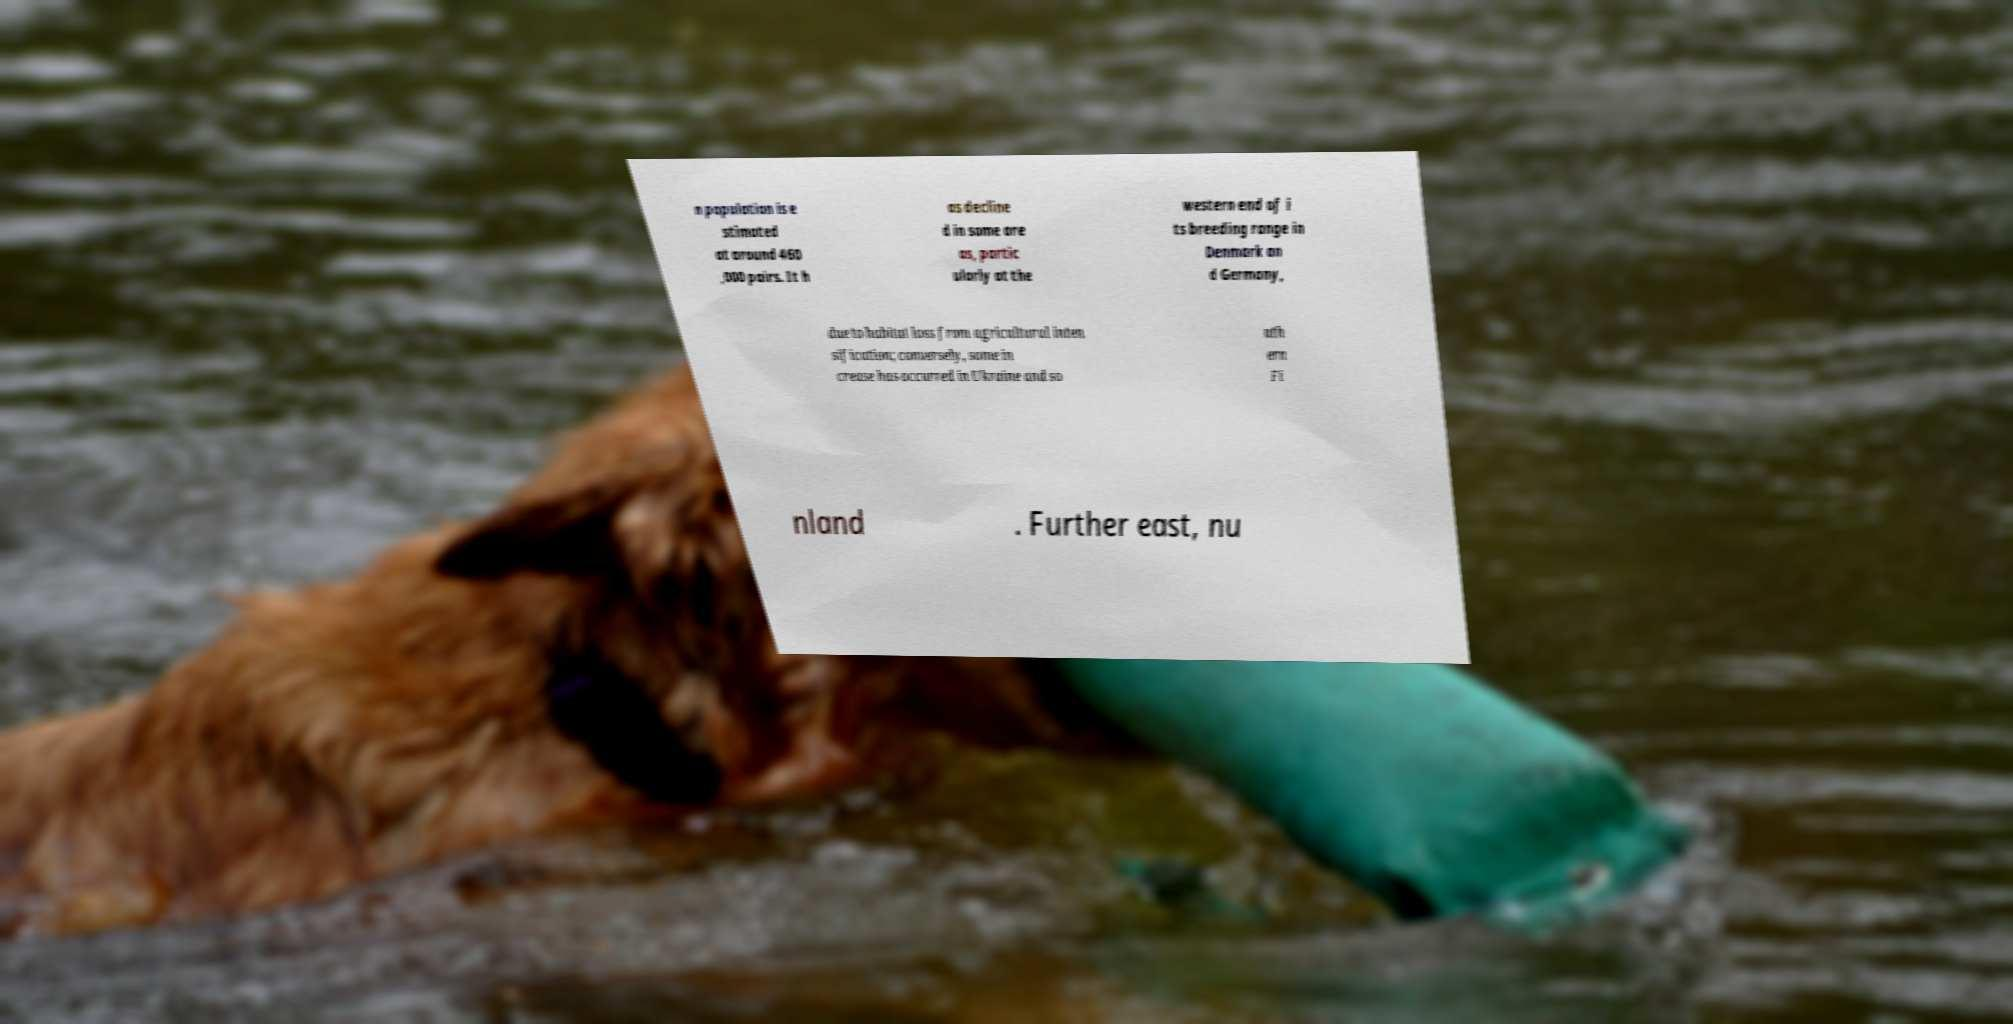What messages or text are displayed in this image? I need them in a readable, typed format. n population is e stimated at around 460 ,000 pairs. It h as decline d in some are as, partic ularly at the western end of i ts breeding range in Denmark an d Germany, due to habitat loss from agricultural inten sification; conversely, some in crease has occurred in Ukraine and so uth ern Fi nland . Further east, nu 